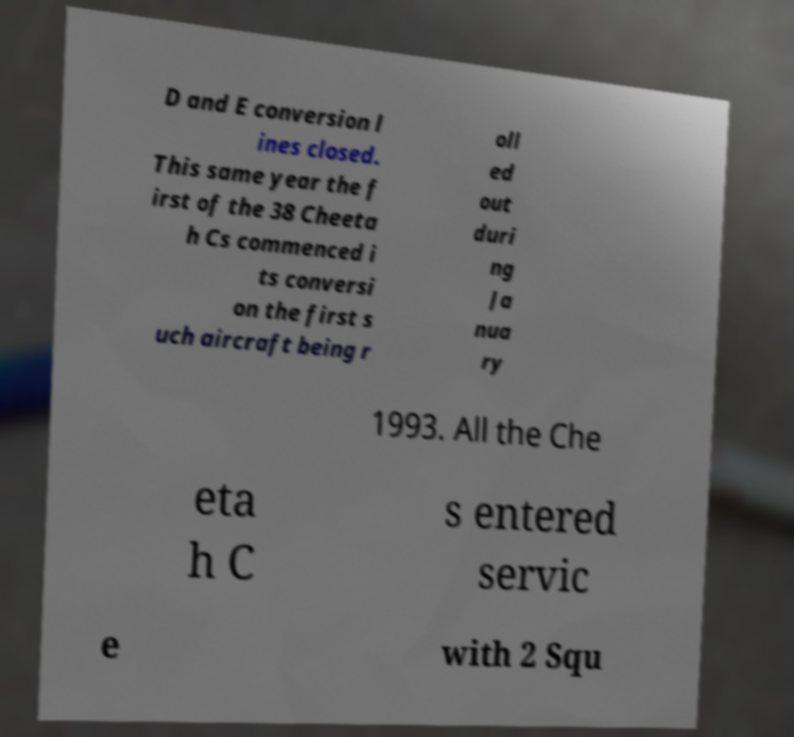There's text embedded in this image that I need extracted. Can you transcribe it verbatim? D and E conversion l ines closed. This same year the f irst of the 38 Cheeta h Cs commenced i ts conversi on the first s uch aircraft being r oll ed out duri ng Ja nua ry 1993. All the Che eta h C s entered servic e with 2 Squ 